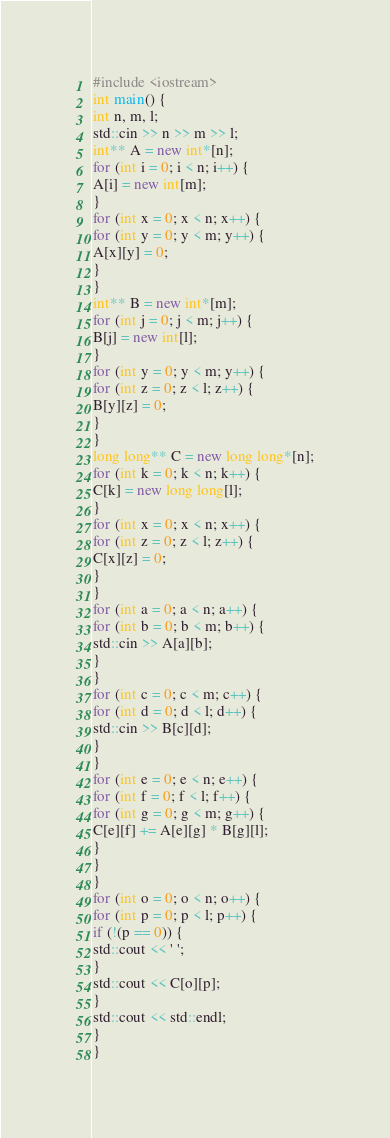<code> <loc_0><loc_0><loc_500><loc_500><_C++_>#include <iostream>
int main() {
int n, m, l;
std::cin >> n >> m >> l;
int** A = new int*[n];
for (int i = 0; i < n; i++) {
A[i] = new int[m];
}
for (int x = 0; x < n; x++) {
for (int y = 0; y < m; y++) {
A[x][y] = 0;
}
}
int** B = new int*[m];
for (int j = 0; j < m; j++) {
B[j] = new int[l];
}
for (int y = 0; y < m; y++) {
for (int z = 0; z < l; z++) {
B[y][z] = 0;
}
}
long long** C = new long long*[n];
for (int k = 0; k < n; k++) {
C[k] = new long long[l];
}
for (int x = 0; x < n; x++) {
for (int z = 0; z < l; z++) {
C[x][z] = 0;
}
}
for (int a = 0; a < n; a++) {
for (int b = 0; b < m; b++) {
std::cin >> A[a][b];
}
}
for (int c = 0; c < m; c++) {
for (int d = 0; d < l; d++) {
std::cin >> B[c][d];
}
}
for (int e = 0; e < n; e++) {
for (int f = 0; f < l; f++) {
for (int g = 0; g < m; g++) {
C[e][f] += A[e][g] * B[g][l];
}
}
}
for (int o = 0; o < n; o++) {
for (int p = 0; p < l; p++) {
if (!(p == 0)) {
std::cout << ' ';
}
std::cout << C[o][p];
}
std::cout << std::endl;
}
}</code> 